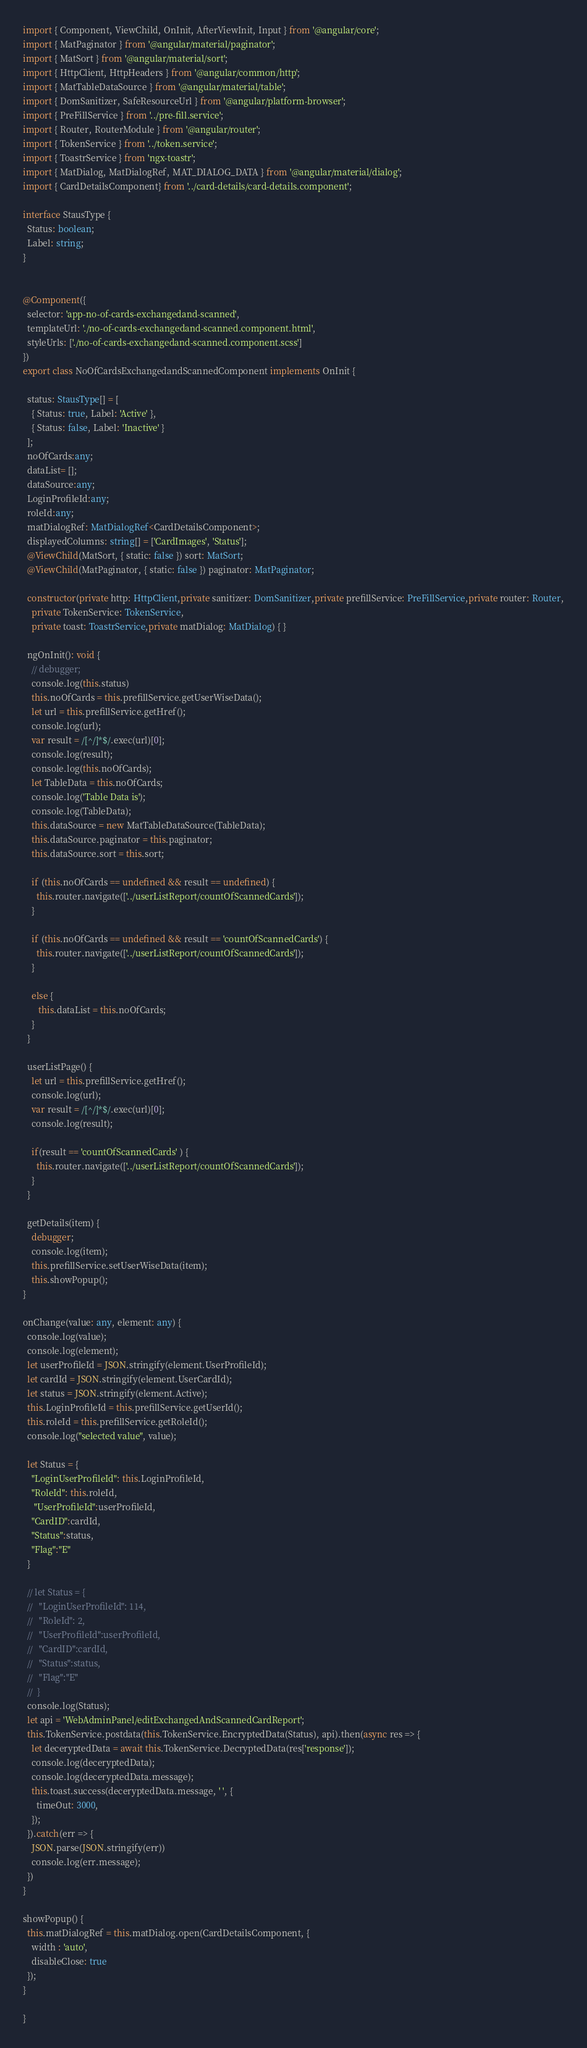<code> <loc_0><loc_0><loc_500><loc_500><_TypeScript_>
import { Component, ViewChild, OnInit, AfterViewInit, Input } from '@angular/core';
import { MatPaginator } from '@angular/material/paginator';
import { MatSort } from '@angular/material/sort';
import { HttpClient, HttpHeaders } from '@angular/common/http';
import { MatTableDataSource } from '@angular/material/table';
import { DomSanitizer, SafeResourceUrl } from '@angular/platform-browser';
import { PreFillService } from '../pre-fill.service';
import { Router, RouterModule } from '@angular/router';
import { TokenService } from '../token.service';
import { ToastrService } from 'ngx-toastr';
import { MatDialog, MatDialogRef, MAT_DIALOG_DATA } from '@angular/material/dialog';
import { CardDetailsComponent} from '../card-details/card-details.component';

interface StausType {
  Status: boolean;
  Label: string;
}


@Component({
  selector: 'app-no-of-cards-exchangedand-scanned',
  templateUrl: './no-of-cards-exchangedand-scanned.component.html',
  styleUrls: ['./no-of-cards-exchangedand-scanned.component.scss']
})
export class NoOfCardsExchangedandScannedComponent implements OnInit {

  status: StausType[] = [
    { Status: true, Label: 'Active' },
    { Status: false, Label: 'Inactive' }
  ];
  noOfCards:any;
  dataList= [];
  dataSource:any;
  LoginProfileId:any;
  roleId:any;
  matDialogRef: MatDialogRef<CardDetailsComponent>;
  displayedColumns: string[] = ['CardImages', 'Status'];
  @ViewChild(MatSort, { static: false }) sort: MatSort;
  @ViewChild(MatPaginator, { static: false }) paginator: MatPaginator;

  constructor(private http: HttpClient,private sanitizer: DomSanitizer,private prefillService: PreFillService,private router: Router,
    private TokenService: TokenService,
    private toast: ToastrService,private matDialog: MatDialog) { }

  ngOnInit(): void {
    // debugger;
    console.log(this.status)
    this.noOfCards = this.prefillService.getUserWiseData();
    let url = this.prefillService.getHref();
    console.log(url);
    var result = /[^/]*$/.exec(url)[0];
    console.log(result);
    console.log(this.noOfCards);
    let TableData = this.noOfCards;
    console.log('Table Data is');
    console.log(TableData);
    this.dataSource = new MatTableDataSource(TableData);
    this.dataSource.paginator = this.paginator;
    this.dataSource.sort = this.sort;

    if (this.noOfCards == undefined && result == undefined) {
      this.router.navigate(['../userListReport/countOfScannedCards']);
    }

    if (this.noOfCards == undefined && result == 'countOfScannedCards') {
      this.router.navigate(['../userListReport/countOfScannedCards']);
    }    
    
    else {
       this.dataList = this.noOfCards;
    }
  }

  userListPage() {
    let url = this.prefillService.getHref();
    console.log(url);
    var result = /[^/]*$/.exec(url)[0];
    console.log(result);

    if(result == 'countOfScannedCards' ) {
      this.router.navigate(['../userListReport/countOfScannedCards']);
    }
  }

  getDetails(item) {
    debugger;     
    console.log(item);
    this.prefillService.setUserWiseData(item);
    this.showPopup();
}

onChange(value: any, element: any) {
  console.log(value);
  console.log(element);
  let userProfileId = JSON.stringify(element.UserProfileId);
  let cardId = JSON.stringify(element.UserCardId);
  let status = JSON.stringify(element.Active);
  this.LoginProfileId = this.prefillService.getUserId();
  this.roleId = this.prefillService.getRoleId();
  console.log("selected value", value);

  let Status = {
    "LoginUserProfileId": this.LoginProfileId,
    "RoleId": this.roleId,
     "UserProfileId":userProfileId,
    "CardID":cardId,
    "Status":status,
    "Flag":"E"
  }

  // let Status = {
  //   "LoginUserProfileId": 114,
  //   "RoleId": 2,
  //   "UserProfileId":userProfileId,
  //   "CardID":cardId,
  //   "Status":status,
  //   "Flag":"E"
  //  }
  console.log(Status);
  let api = 'WebAdminPanel/editExchangedAndScannedCardReport';
  this.TokenService.postdata(this.TokenService.EncryptedData(Status), api).then(async res => {
    let deceryptedData = await this.TokenService.DecryptedData(res['response']);
    console.log(deceryptedData);
    console.log(deceryptedData.message);
    this.toast.success(deceryptedData.message, ' ', {
      timeOut: 3000,
    });
  }).catch(err => {
    JSON.parse(JSON.stringify(err))
    console.log(err.message);
  })
}

showPopup() {
  this.matDialogRef = this.matDialog.open(CardDetailsComponent, {   
    width : 'auto',      
    disableClose: true
  });
}

}
</code> 